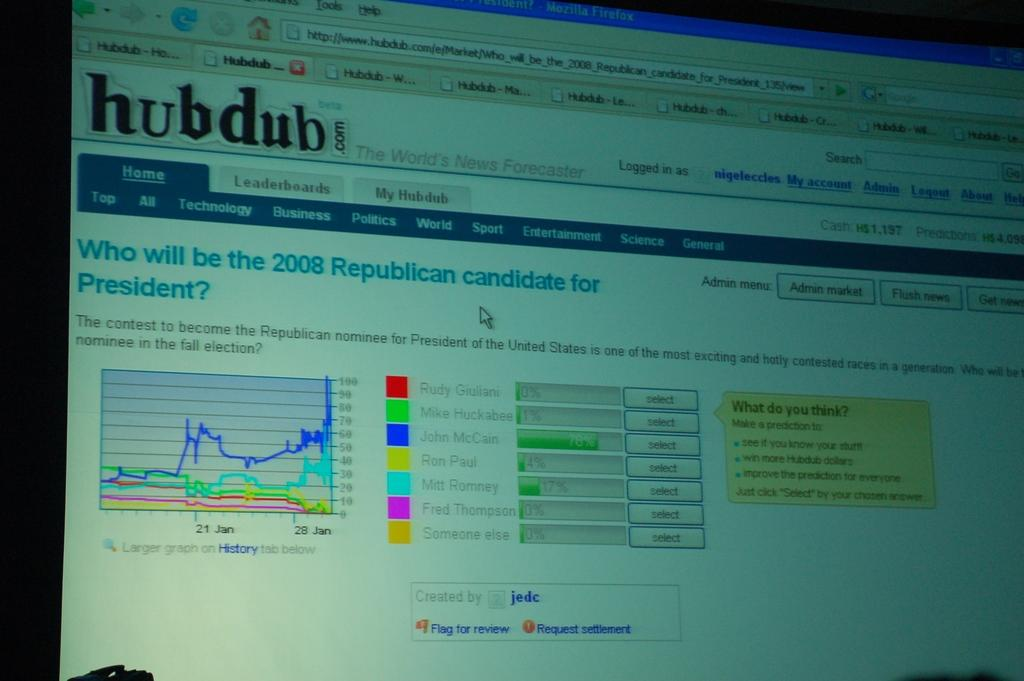<image>
Give a short and clear explanation of the subsequent image. a computer monitor open to a web window for HUB Dub 